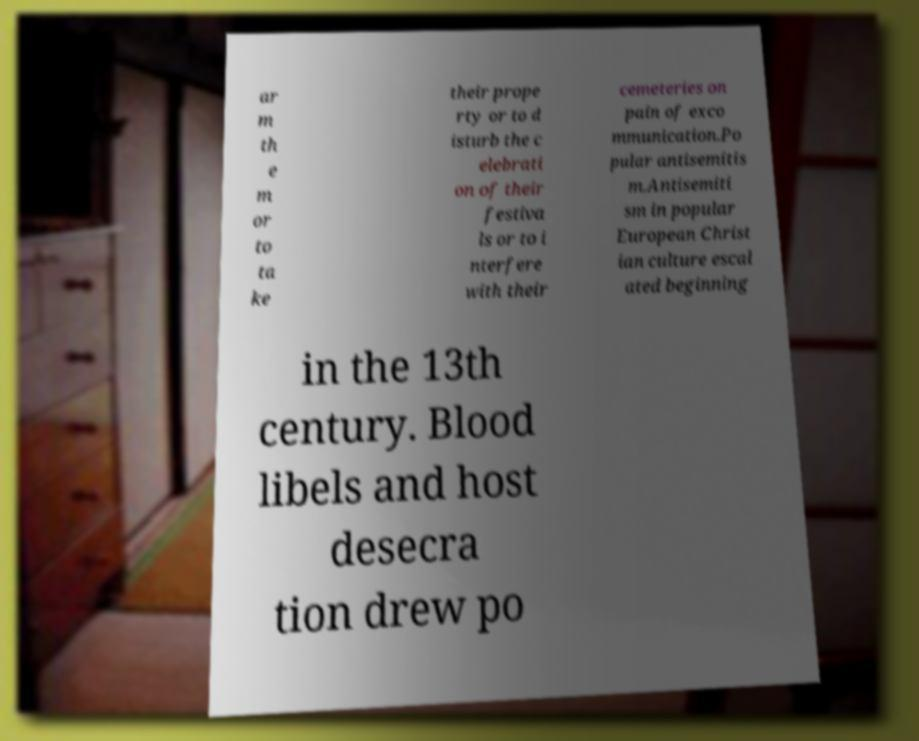There's text embedded in this image that I need extracted. Can you transcribe it verbatim? ar m th e m or to ta ke their prope rty or to d isturb the c elebrati on of their festiva ls or to i nterfere with their cemeteries on pain of exco mmunication.Po pular antisemitis m.Antisemiti sm in popular European Christ ian culture escal ated beginning in the 13th century. Blood libels and host desecra tion drew po 